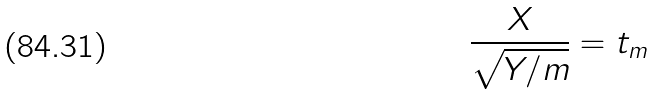Convert formula to latex. <formula><loc_0><loc_0><loc_500><loc_500>\frac { X } { \sqrt { Y / m } } = t _ { m }</formula> 